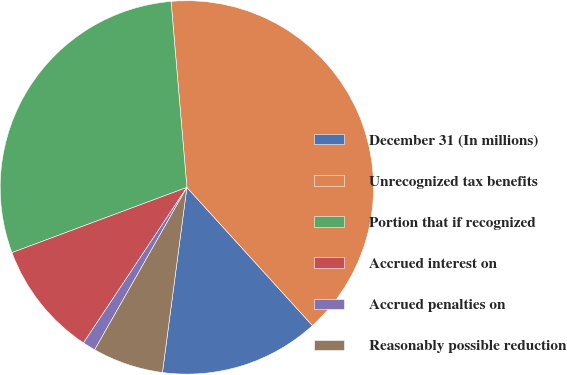Convert chart to OTSL. <chart><loc_0><loc_0><loc_500><loc_500><pie_chart><fcel>December 31 (In millions)<fcel>Unrecognized tax benefits<fcel>Portion that if recognized<fcel>Accrued interest on<fcel>Accrued penalties on<fcel>Reasonably possible reduction<nl><fcel>13.83%<fcel>39.61%<fcel>29.33%<fcel>9.98%<fcel>1.12%<fcel>6.13%<nl></chart> 